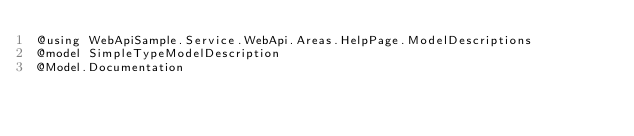Convert code to text. <code><loc_0><loc_0><loc_500><loc_500><_C#_>@using WebApiSample.Service.WebApi.Areas.HelpPage.ModelDescriptions
@model SimpleTypeModelDescription
@Model.Documentation</code> 